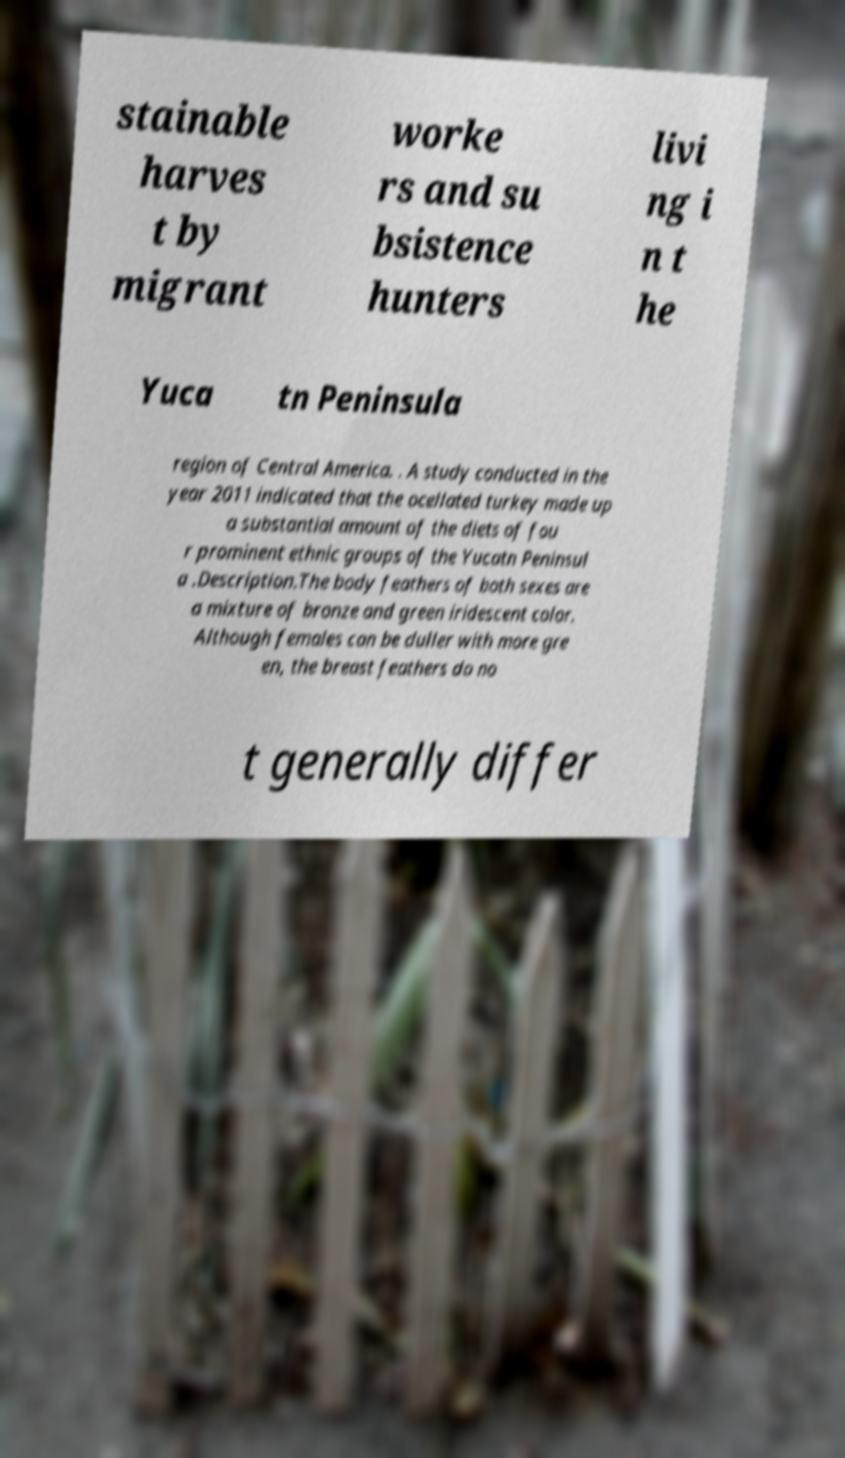I need the written content from this picture converted into text. Can you do that? stainable harves t by migrant worke rs and su bsistence hunters livi ng i n t he Yuca tn Peninsula region of Central America. . A study conducted in the year 2011 indicated that the ocellated turkey made up a substantial amount of the diets of fou r prominent ethnic groups of the Yucatn Peninsul a .Description.The body feathers of both sexes are a mixture of bronze and green iridescent color. Although females can be duller with more gre en, the breast feathers do no t generally differ 